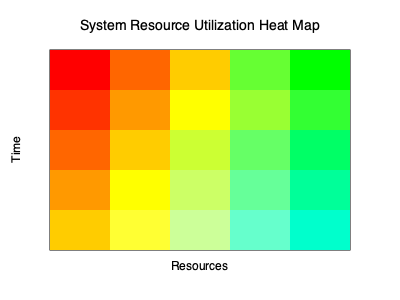Based on the heat map of system resource utilization shown above, which resource appears to be the most likely bottleneck, and at what time period does it reach its peak utilization? To identify the most likely bottleneck and its peak utilization time, we need to analyze the heat map systematically:

1. Understand the heat map:
   - The x-axis represents different system resources.
   - The y-axis represents time periods (from top to bottom).
   - Colors indicate utilization levels: Red (high) to Green (low).

2. Identify the hottest (reddest) areas:
   - The top-left corner shows the darkest red color.
   - This indicates the highest utilization.

3. Determine the resource:
   - The leftmost column represents the first resource.
   - This is likely CPU, memory, or another critical resource.

4. Determine the time period:
   - The topmost row represents the earliest time period.

5. Analyze the pattern:
   - The leftmost column consistently shows the hottest colors.
   - This suggests that this resource is consistently under high load.

6. Identify peak utilization:
   - The darkest red appears in the top-left cell.
   - This indicates peak utilization in the earliest time period.

7. Consider bottleneck definition:
   - A bottleneck is a resource that limits overall system performance.
   - The consistently high utilization of the leftmost resource suggests it's the bottleneck.

Therefore, the leftmost resource is the most likely bottleneck, reaching peak utilization in the earliest time period (top row of the heat map).
Answer: Leftmost resource, earliest time period 